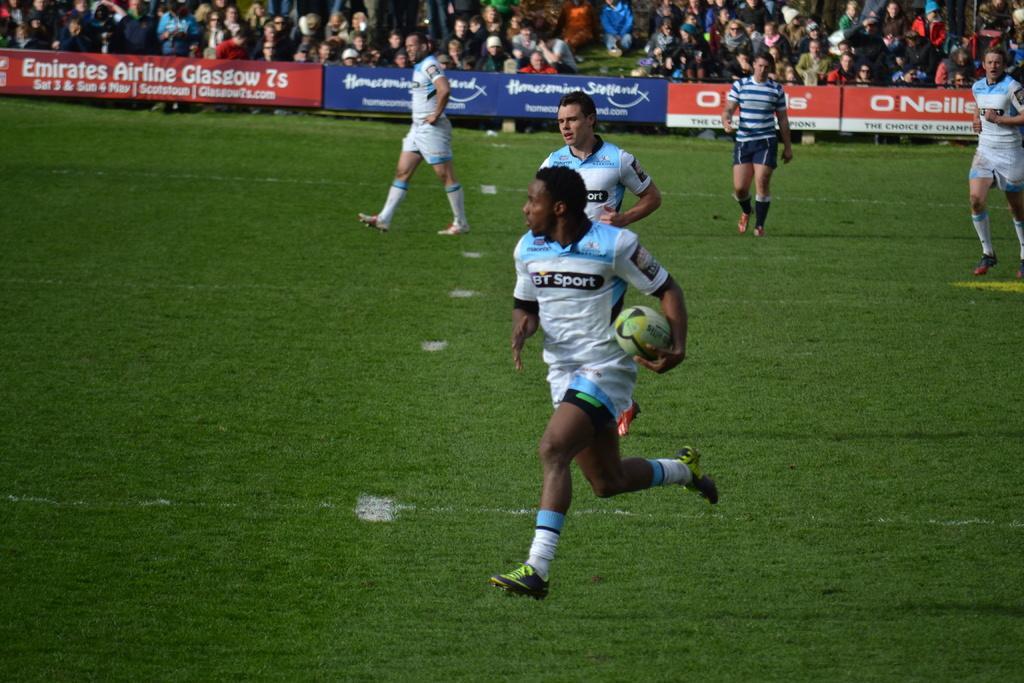In one or two sentences, can you explain what this image depicts? This picture describes about group of people and few people playing game in the ground, in the middle of the image we can see a man, he is holding a ball, in the background we can see hoardings. 